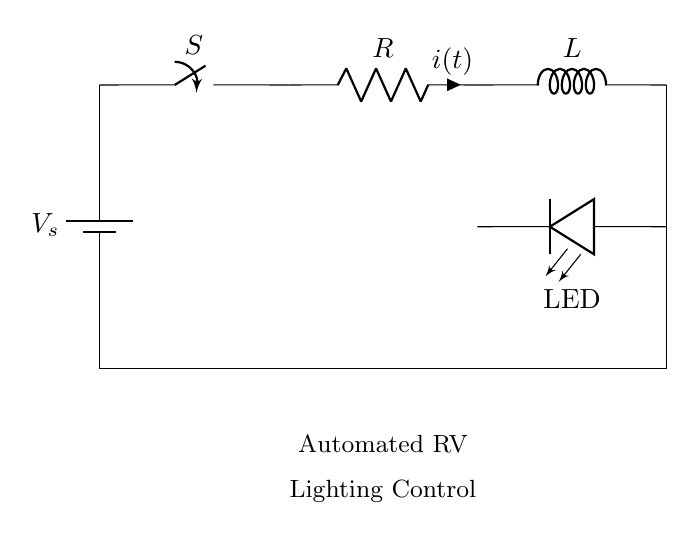What is the function of the switch in this circuit? The switch controls the flow of current; when closed, it allows current to flow through the circuit.
Answer: controls current flow What is the role of the resistor in this RL circuit? The resistor limits the amount of current in the circuit, affecting the timing characteristics of the lighting.
Answer: limits current What type of components are used in this circuit? The circuit comprises a switch, resistor, inductor, battery, and LED.
Answer: switch, resistor, inductor, battery, LED How does the inductor influence the circuit's behavior? The inductor stores energy in the magnetic field and affects the timing delay by resisting changes in current flow.
Answer: stores energy What does the LED in the circuit represent? The LED represents the automated RV lighting, indicating the operation of the circuit.
Answer: RV lighting What is the effect of increasing the resistance value on the timing in this circuit? Increasing resistance slows down the rate at which current builds up, resulting in a longer timing delay for the lighting.
Answer: increases timing delay What will happen when the switch is opened? Opening the switch interrupts the current flow, causing the LED to turn off and stopping any operation of the lighting.
Answer: turns off lighting 